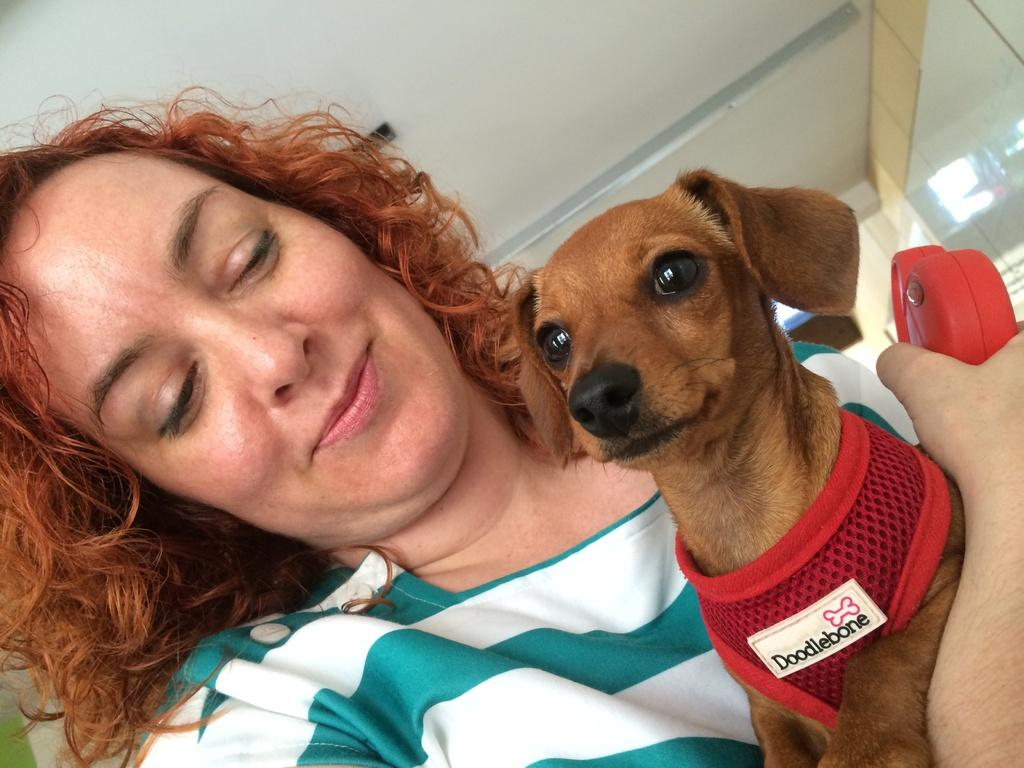Who is present in the image? There is a woman in the image. What is the woman wearing? The woman is wearing a white and green t-shirt. What is the woman holding in the image? The woman is holding a dog. How is the dog dressed in the image? The dog is wearing a dress. What can be seen in the background of the image? There is a roof top and a glass door in the background of the image. What type of camera can be seen in the image? There is no camera present in the image. What kind of cloud is visible in the image? There are no clouds visible in the image. 